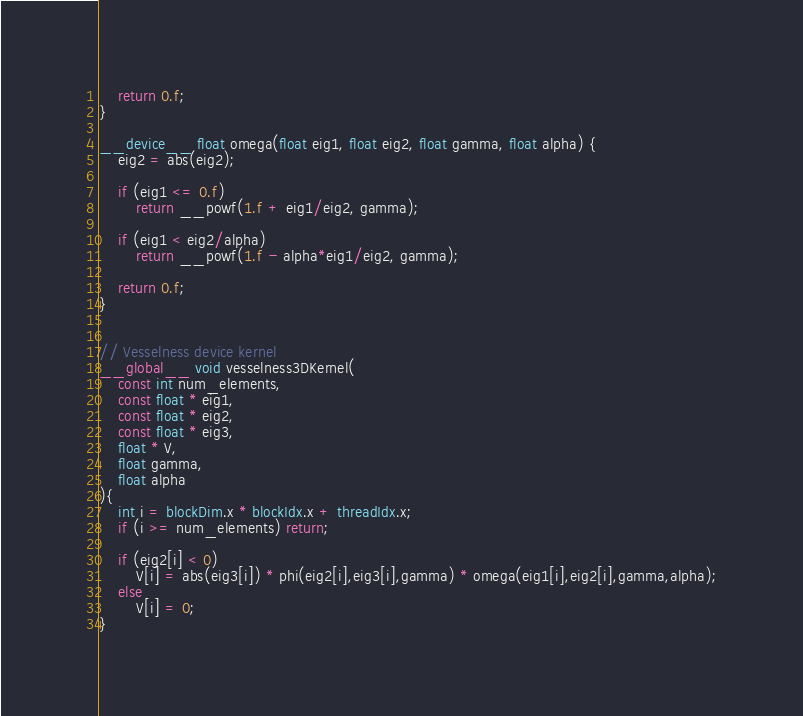Convert code to text. <code><loc_0><loc_0><loc_500><loc_500><_Cuda_>	return 0.f;
}

__device__ float omega(float eig1, float eig2, float gamma, float alpha) {
	eig2 = abs(eig2);

	if (eig1 <= 0.f)
		return __powf(1.f + eig1/eig2, gamma);

	if (eig1 < eig2/alpha)
		return __powf(1.f - alpha*eig1/eig2, gamma);

	return 0.f;
}


// Vesselness device kernel
__global__ void vesselness3DKernel(
	const int num_elements,
	const float * eig1,
	const float * eig2,
	const float * eig3,
	float * V,
	float gamma,
	float alpha
){
	int i = blockDim.x * blockIdx.x + threadIdx.x;
	if (i >= num_elements) return;

	if (eig2[i] < 0)
		V[i] = abs(eig3[i]) * phi(eig2[i],eig3[i],gamma) * omega(eig1[i],eig2[i],gamma,alpha);
	else
		V[i] = 0;
}
</code> 